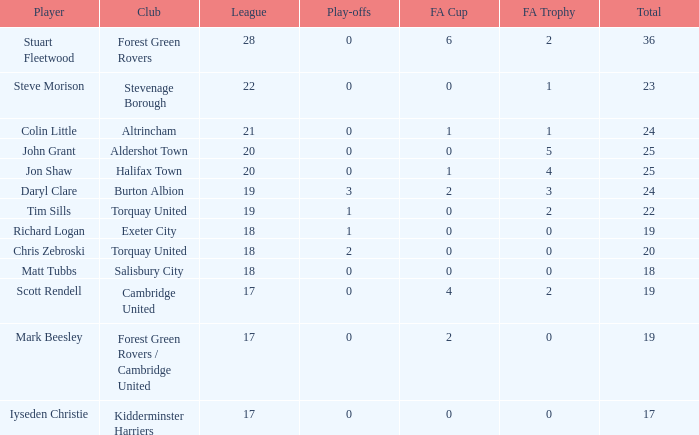Which of the lowest FA Trophys involved the Forest Green Rovers club when the play-offs number was bigger than 0? None. 